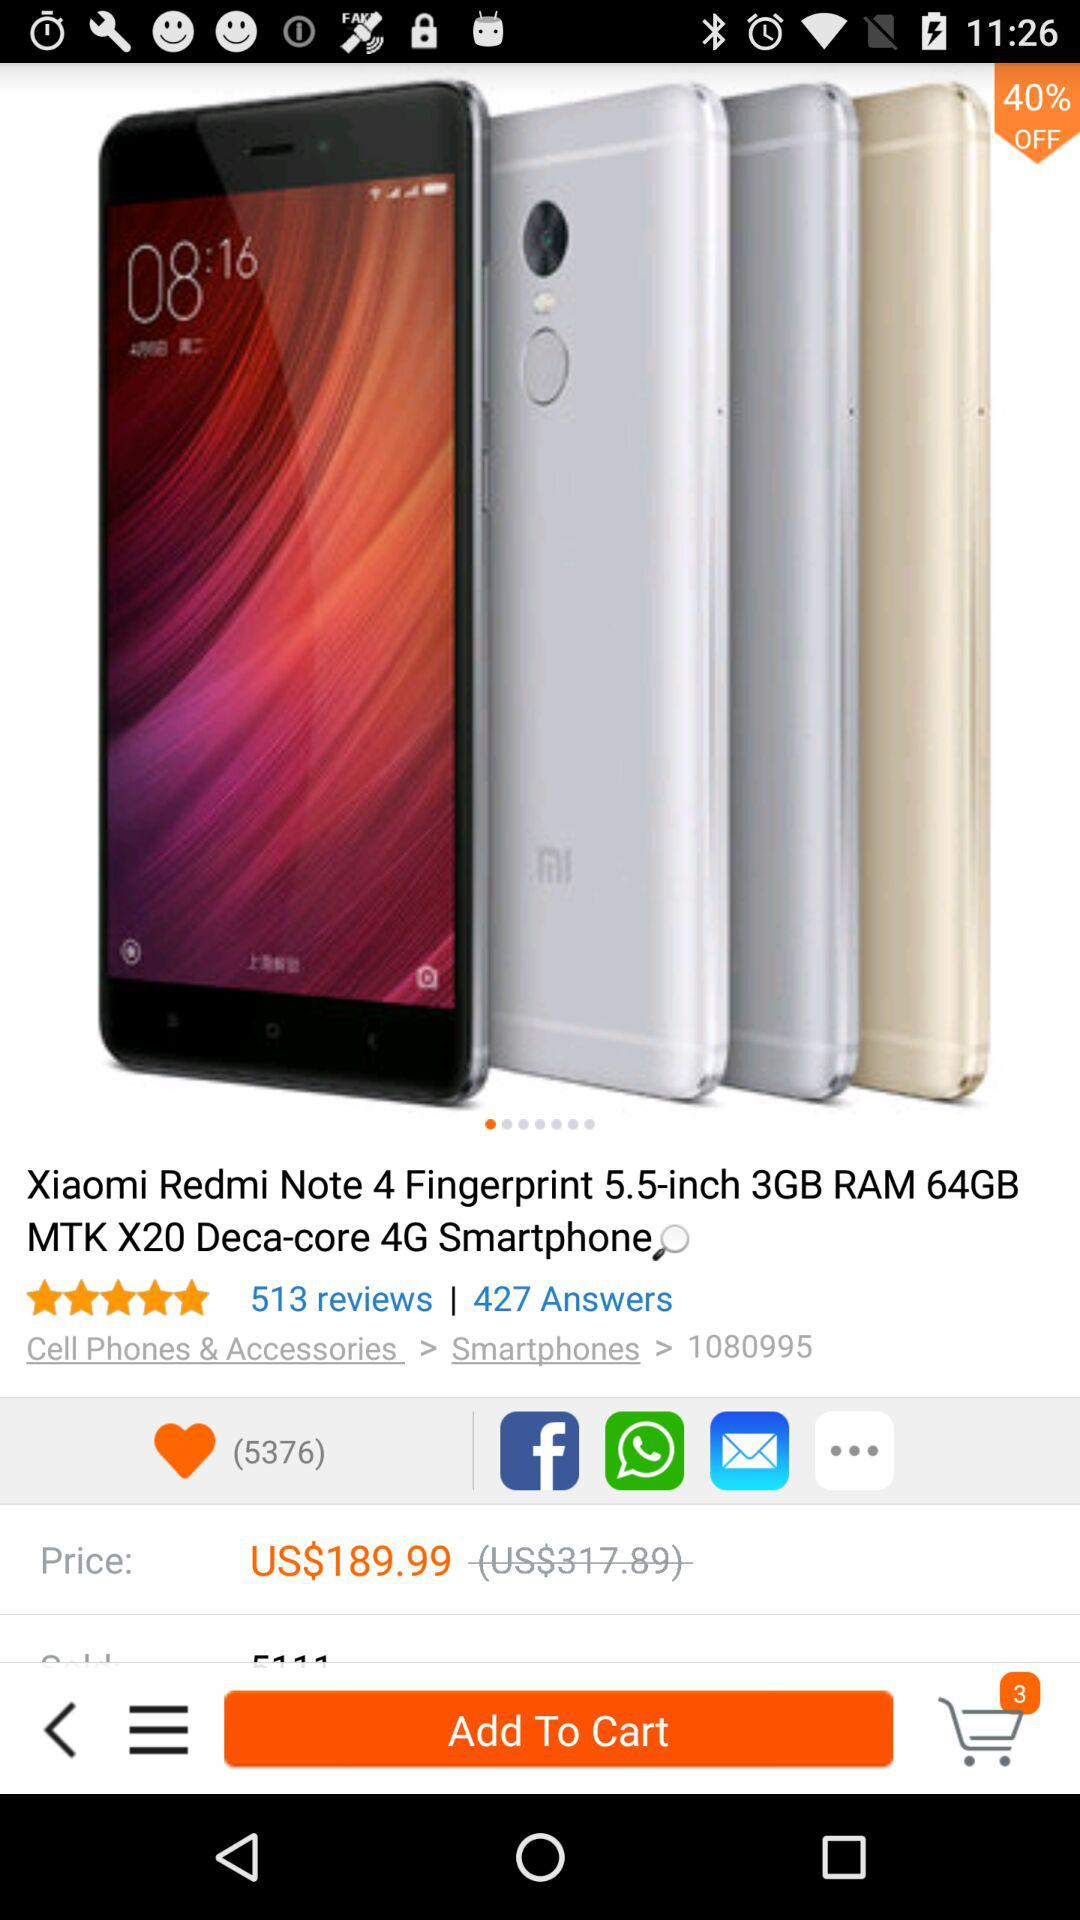What is the review count for "Xiaomi Redmi Note 4"? The review count is 513. 